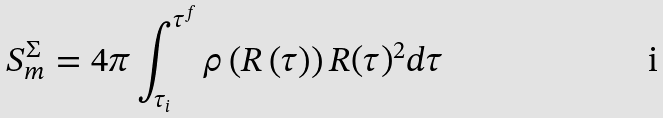<formula> <loc_0><loc_0><loc_500><loc_500>S _ { m } ^ { \Sigma } = 4 \pi \int _ { \tau _ { i } } ^ { \tau ^ { f } } \rho \left ( R \left ( \tau \right ) \right ) R ( \tau ) ^ { 2 } d \tau</formula> 